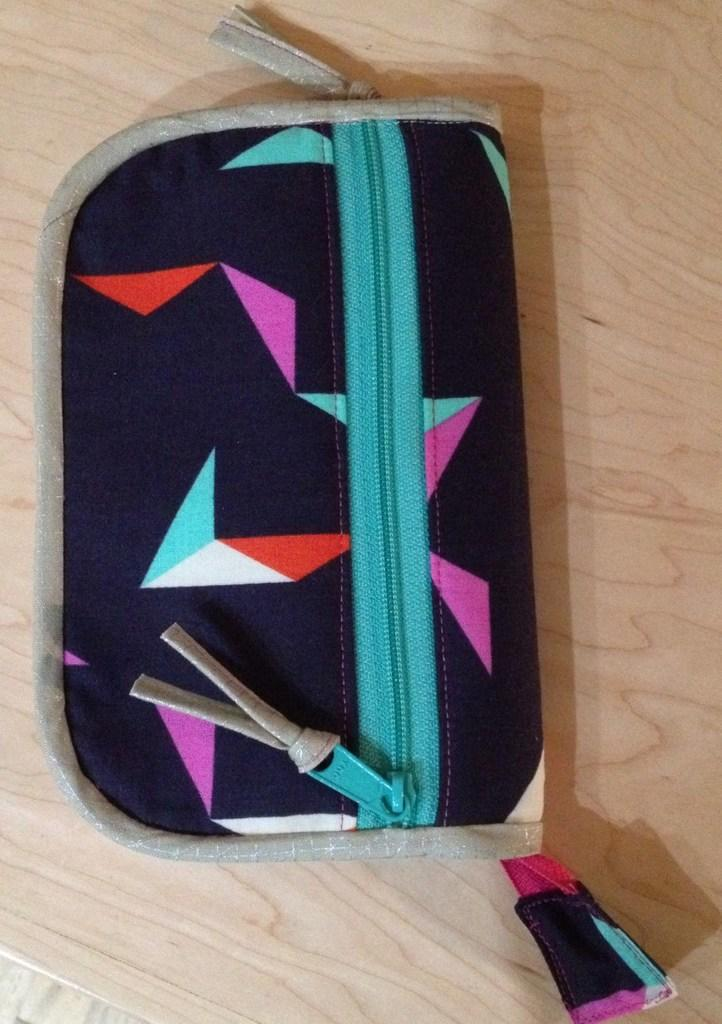What object can be seen in the image? There is a purse in the image. Where is the purse located? The purse is on a wooden table. What type of feast is being prepared on the wooden table in the image? There is no feast or any indication of food preparation in the image; it only shows a purse on a wooden table. 